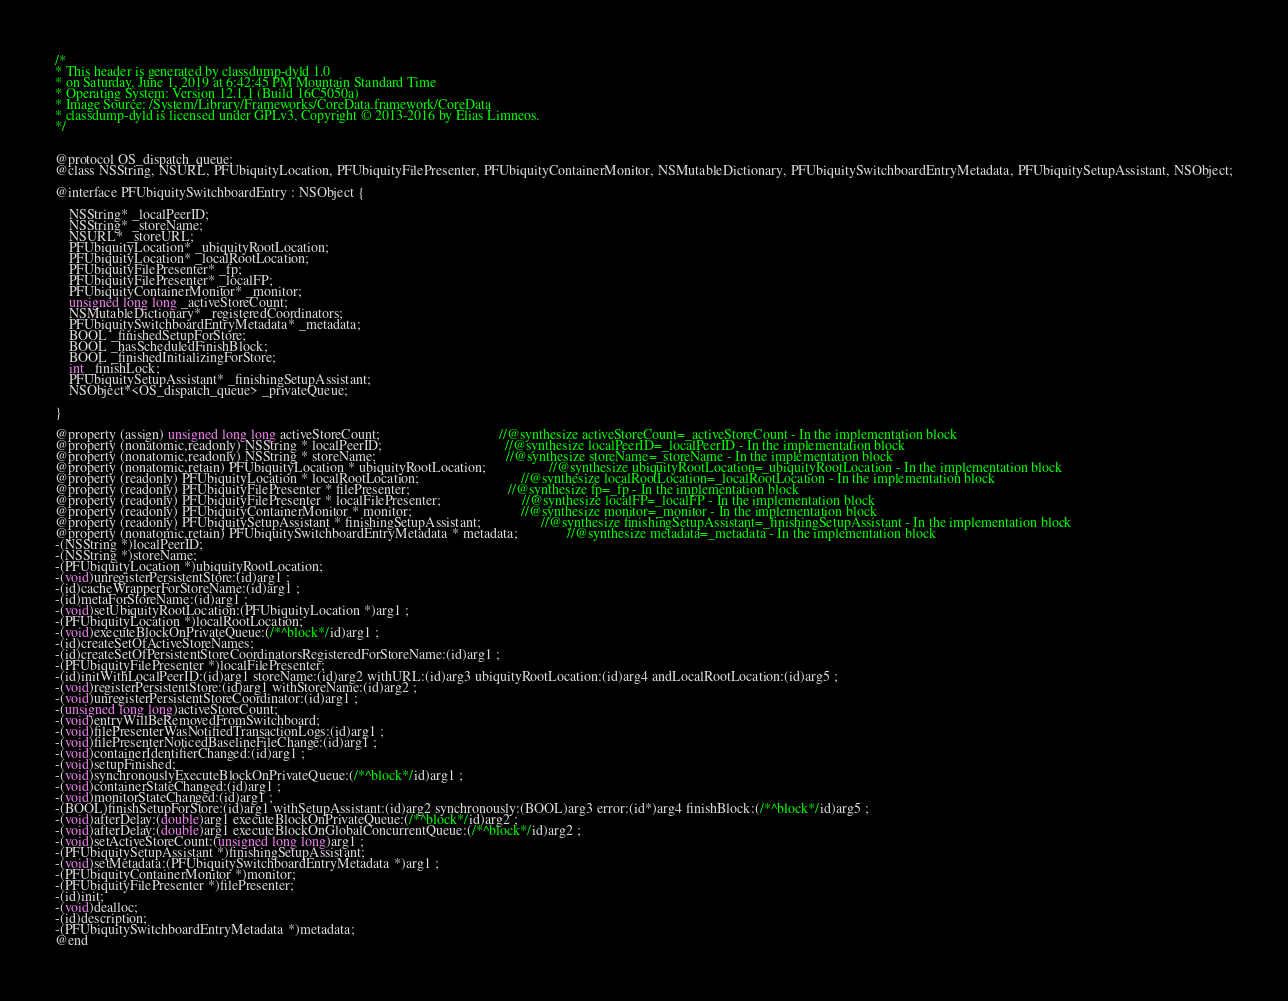Convert code to text. <code><loc_0><loc_0><loc_500><loc_500><_C_>/*
* This header is generated by classdump-dyld 1.0
* on Saturday, June 1, 2019 at 6:42:45 PM Mountain Standard Time
* Operating System: Version 12.1.1 (Build 16C5050a)
* Image Source: /System/Library/Frameworks/CoreData.framework/CoreData
* classdump-dyld is licensed under GPLv3, Copyright © 2013-2016 by Elias Limneos.
*/


@protocol OS_dispatch_queue;
@class NSString, NSURL, PFUbiquityLocation, PFUbiquityFilePresenter, PFUbiquityContainerMonitor, NSMutableDictionary, PFUbiquitySwitchboardEntryMetadata, PFUbiquitySetupAssistant, NSObject;

@interface PFUbiquitySwitchboardEntry : NSObject {

	NSString* _localPeerID;
	NSString* _storeName;
	NSURL* _storeURL;
	PFUbiquityLocation* _ubiquityRootLocation;
	PFUbiquityLocation* _localRootLocation;
	PFUbiquityFilePresenter* _fp;
	PFUbiquityFilePresenter* _localFP;
	PFUbiquityContainerMonitor* _monitor;
	unsigned long long _activeStoreCount;
	NSMutableDictionary* _registeredCoordinators;
	PFUbiquitySwitchboardEntryMetadata* _metadata;
	BOOL _finishedSetupForStore;
	BOOL _hasScheduledFinishBlock;
	BOOL _finishedInitializingForStore;
	int _finishLock;
	PFUbiquitySetupAssistant* _finishingSetupAssistant;
	NSObject*<OS_dispatch_queue> _privateQueue;

}

@property (assign) unsigned long long activeStoreCount;                                  //@synthesize activeStoreCount=_activeStoreCount - In the implementation block
@property (nonatomic,readonly) NSString * localPeerID;                                   //@synthesize localPeerID=_localPeerID - In the implementation block
@property (nonatomic,readonly) NSString * storeName;                                     //@synthesize storeName=_storeName - In the implementation block
@property (nonatomic,retain) PFUbiquityLocation * ubiquityRootLocation;                  //@synthesize ubiquityRootLocation=_ubiquityRootLocation - In the implementation block
@property (readonly) PFUbiquityLocation * localRootLocation;                             //@synthesize localRootLocation=_localRootLocation - In the implementation block
@property (readonly) PFUbiquityFilePresenter * filePresenter;                            //@synthesize fp=_fp - In the implementation block
@property (readonly) PFUbiquityFilePresenter * localFilePresenter;                       //@synthesize localFP=_localFP - In the implementation block
@property (readonly) PFUbiquityContainerMonitor * monitor;                               //@synthesize monitor=_monitor - In the implementation block
@property (readonly) PFUbiquitySetupAssistant * finishingSetupAssistant;                 //@synthesize finishingSetupAssistant=_finishingSetupAssistant - In the implementation block
@property (nonatomic,retain) PFUbiquitySwitchboardEntryMetadata * metadata;              //@synthesize metadata=_metadata - In the implementation block
-(NSString *)localPeerID;
-(NSString *)storeName;
-(PFUbiquityLocation *)ubiquityRootLocation;
-(void)unregisterPersistentStore:(id)arg1 ;
-(id)cacheWrapperForStoreName:(id)arg1 ;
-(id)metaForStoreName:(id)arg1 ;
-(void)setUbiquityRootLocation:(PFUbiquityLocation *)arg1 ;
-(PFUbiquityLocation *)localRootLocation;
-(void)executeBlockOnPrivateQueue:(/*^block*/id)arg1 ;
-(id)createSetOfActiveStoreNames;
-(id)createSetOfPersistentStoreCoordinatorsRegisteredForStoreName:(id)arg1 ;
-(PFUbiquityFilePresenter *)localFilePresenter;
-(id)initWithLocalPeerID:(id)arg1 storeName:(id)arg2 withURL:(id)arg3 ubiquityRootLocation:(id)arg4 andLocalRootLocation:(id)arg5 ;
-(void)registerPersistentStore:(id)arg1 withStoreName:(id)arg2 ;
-(void)unregisterPersistentStoreCoordinator:(id)arg1 ;
-(unsigned long long)activeStoreCount;
-(void)entryWillBeRemovedFromSwitchboard;
-(void)filePresenterWasNotifiedTransactionLogs:(id)arg1 ;
-(void)filePresenterNoticedBaselineFileChange:(id)arg1 ;
-(void)containerIdentifierChanged:(id)arg1 ;
-(void)setupFinished;
-(void)synchronouslyExecuteBlockOnPrivateQueue:(/*^block*/id)arg1 ;
-(void)containerStateChanged:(id)arg1 ;
-(void)monitorStateChanged:(id)arg1 ;
-(BOOL)finishSetupForStore:(id)arg1 withSetupAssistant:(id)arg2 synchronously:(BOOL)arg3 error:(id*)arg4 finishBlock:(/*^block*/id)arg5 ;
-(void)afterDelay:(double)arg1 executeBlockOnPrivateQueue:(/*^block*/id)arg2 ;
-(void)afterDelay:(double)arg1 executeBlockOnGlobalConcurrentQueue:(/*^block*/id)arg2 ;
-(void)setActiveStoreCount:(unsigned long long)arg1 ;
-(PFUbiquitySetupAssistant *)finishingSetupAssistant;
-(void)setMetadata:(PFUbiquitySwitchboardEntryMetadata *)arg1 ;
-(PFUbiquityContainerMonitor *)monitor;
-(PFUbiquityFilePresenter *)filePresenter;
-(id)init;
-(void)dealloc;
-(id)description;
-(PFUbiquitySwitchboardEntryMetadata *)metadata;
@end

</code> 